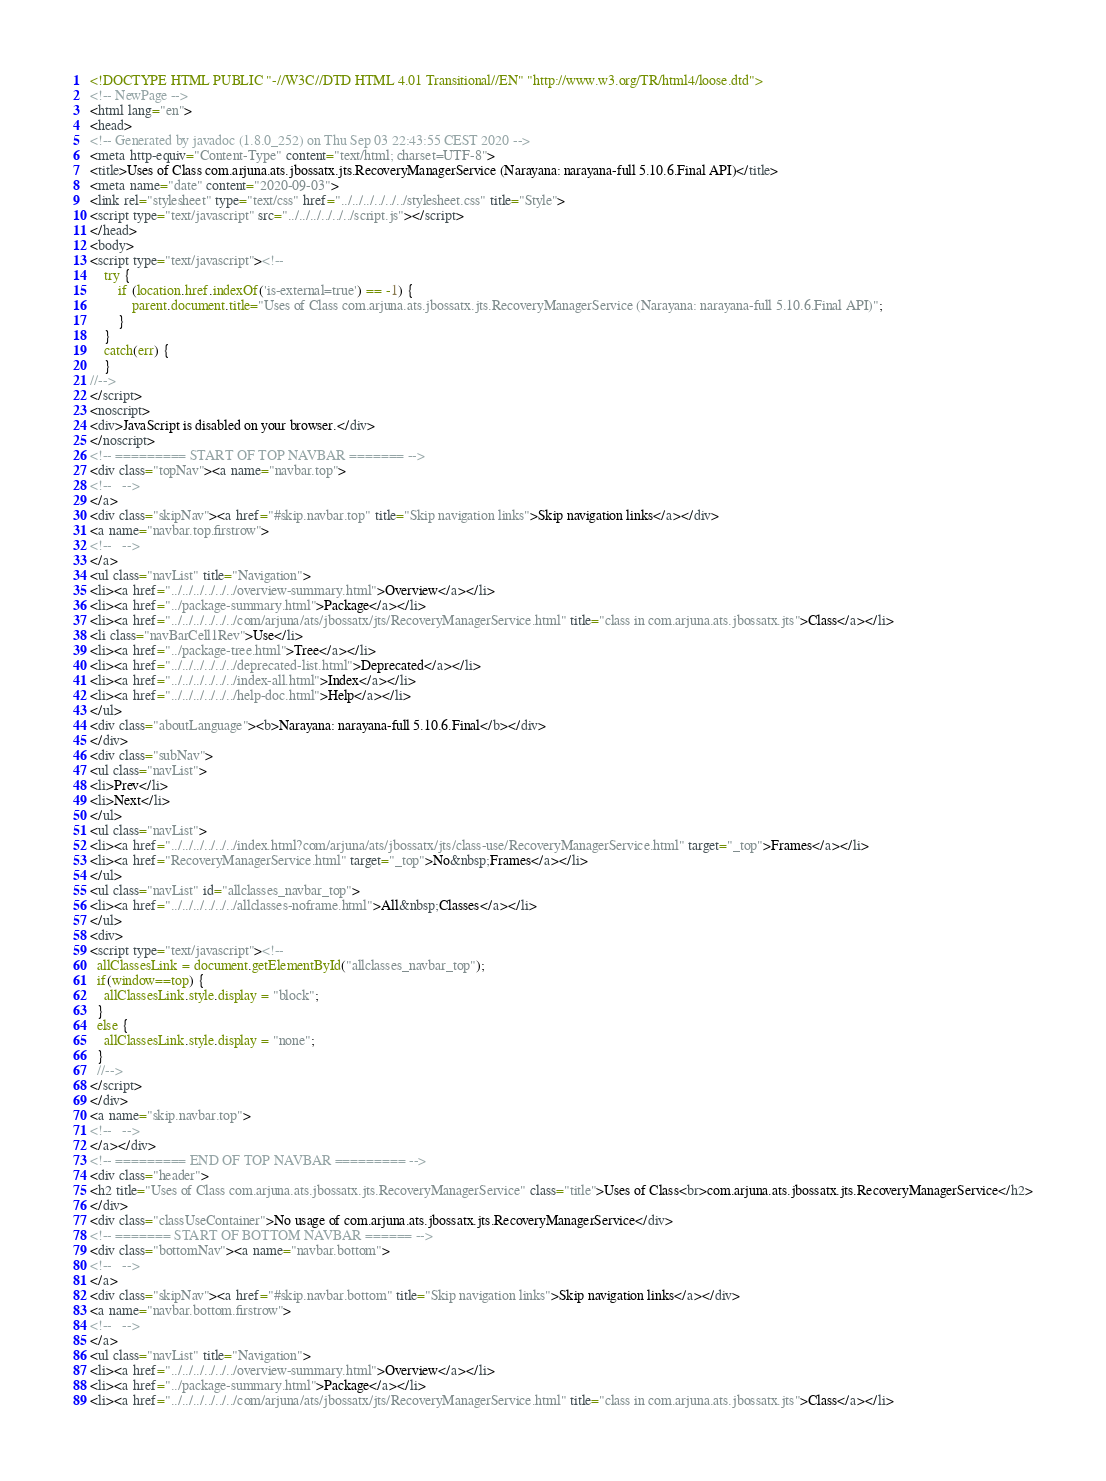Convert code to text. <code><loc_0><loc_0><loc_500><loc_500><_HTML_><!DOCTYPE HTML PUBLIC "-//W3C//DTD HTML 4.01 Transitional//EN" "http://www.w3.org/TR/html4/loose.dtd">
<!-- NewPage -->
<html lang="en">
<head>
<!-- Generated by javadoc (1.8.0_252) on Thu Sep 03 22:43:55 CEST 2020 -->
<meta http-equiv="Content-Type" content="text/html; charset=UTF-8">
<title>Uses of Class com.arjuna.ats.jbossatx.jts.RecoveryManagerService (Narayana: narayana-full 5.10.6.Final API)</title>
<meta name="date" content="2020-09-03">
<link rel="stylesheet" type="text/css" href="../../../../../../stylesheet.css" title="Style">
<script type="text/javascript" src="../../../../../../script.js"></script>
</head>
<body>
<script type="text/javascript"><!--
    try {
        if (location.href.indexOf('is-external=true') == -1) {
            parent.document.title="Uses of Class com.arjuna.ats.jbossatx.jts.RecoveryManagerService (Narayana: narayana-full 5.10.6.Final API)";
        }
    }
    catch(err) {
    }
//-->
</script>
<noscript>
<div>JavaScript is disabled on your browser.</div>
</noscript>
<!-- ========= START OF TOP NAVBAR ======= -->
<div class="topNav"><a name="navbar.top">
<!--   -->
</a>
<div class="skipNav"><a href="#skip.navbar.top" title="Skip navigation links">Skip navigation links</a></div>
<a name="navbar.top.firstrow">
<!--   -->
</a>
<ul class="navList" title="Navigation">
<li><a href="../../../../../../overview-summary.html">Overview</a></li>
<li><a href="../package-summary.html">Package</a></li>
<li><a href="../../../../../../com/arjuna/ats/jbossatx/jts/RecoveryManagerService.html" title="class in com.arjuna.ats.jbossatx.jts">Class</a></li>
<li class="navBarCell1Rev">Use</li>
<li><a href="../package-tree.html">Tree</a></li>
<li><a href="../../../../../../deprecated-list.html">Deprecated</a></li>
<li><a href="../../../../../../index-all.html">Index</a></li>
<li><a href="../../../../../../help-doc.html">Help</a></li>
</ul>
<div class="aboutLanguage"><b>Narayana: narayana-full 5.10.6.Final</b></div>
</div>
<div class="subNav">
<ul class="navList">
<li>Prev</li>
<li>Next</li>
</ul>
<ul class="navList">
<li><a href="../../../../../../index.html?com/arjuna/ats/jbossatx/jts/class-use/RecoveryManagerService.html" target="_top">Frames</a></li>
<li><a href="RecoveryManagerService.html" target="_top">No&nbsp;Frames</a></li>
</ul>
<ul class="navList" id="allclasses_navbar_top">
<li><a href="../../../../../../allclasses-noframe.html">All&nbsp;Classes</a></li>
</ul>
<div>
<script type="text/javascript"><!--
  allClassesLink = document.getElementById("allclasses_navbar_top");
  if(window==top) {
    allClassesLink.style.display = "block";
  }
  else {
    allClassesLink.style.display = "none";
  }
  //-->
</script>
</div>
<a name="skip.navbar.top">
<!--   -->
</a></div>
<!-- ========= END OF TOP NAVBAR ========= -->
<div class="header">
<h2 title="Uses of Class com.arjuna.ats.jbossatx.jts.RecoveryManagerService" class="title">Uses of Class<br>com.arjuna.ats.jbossatx.jts.RecoveryManagerService</h2>
</div>
<div class="classUseContainer">No usage of com.arjuna.ats.jbossatx.jts.RecoveryManagerService</div>
<!-- ======= START OF BOTTOM NAVBAR ====== -->
<div class="bottomNav"><a name="navbar.bottom">
<!--   -->
</a>
<div class="skipNav"><a href="#skip.navbar.bottom" title="Skip navigation links">Skip navigation links</a></div>
<a name="navbar.bottom.firstrow">
<!--   -->
</a>
<ul class="navList" title="Navigation">
<li><a href="../../../../../../overview-summary.html">Overview</a></li>
<li><a href="../package-summary.html">Package</a></li>
<li><a href="../../../../../../com/arjuna/ats/jbossatx/jts/RecoveryManagerService.html" title="class in com.arjuna.ats.jbossatx.jts">Class</a></li></code> 